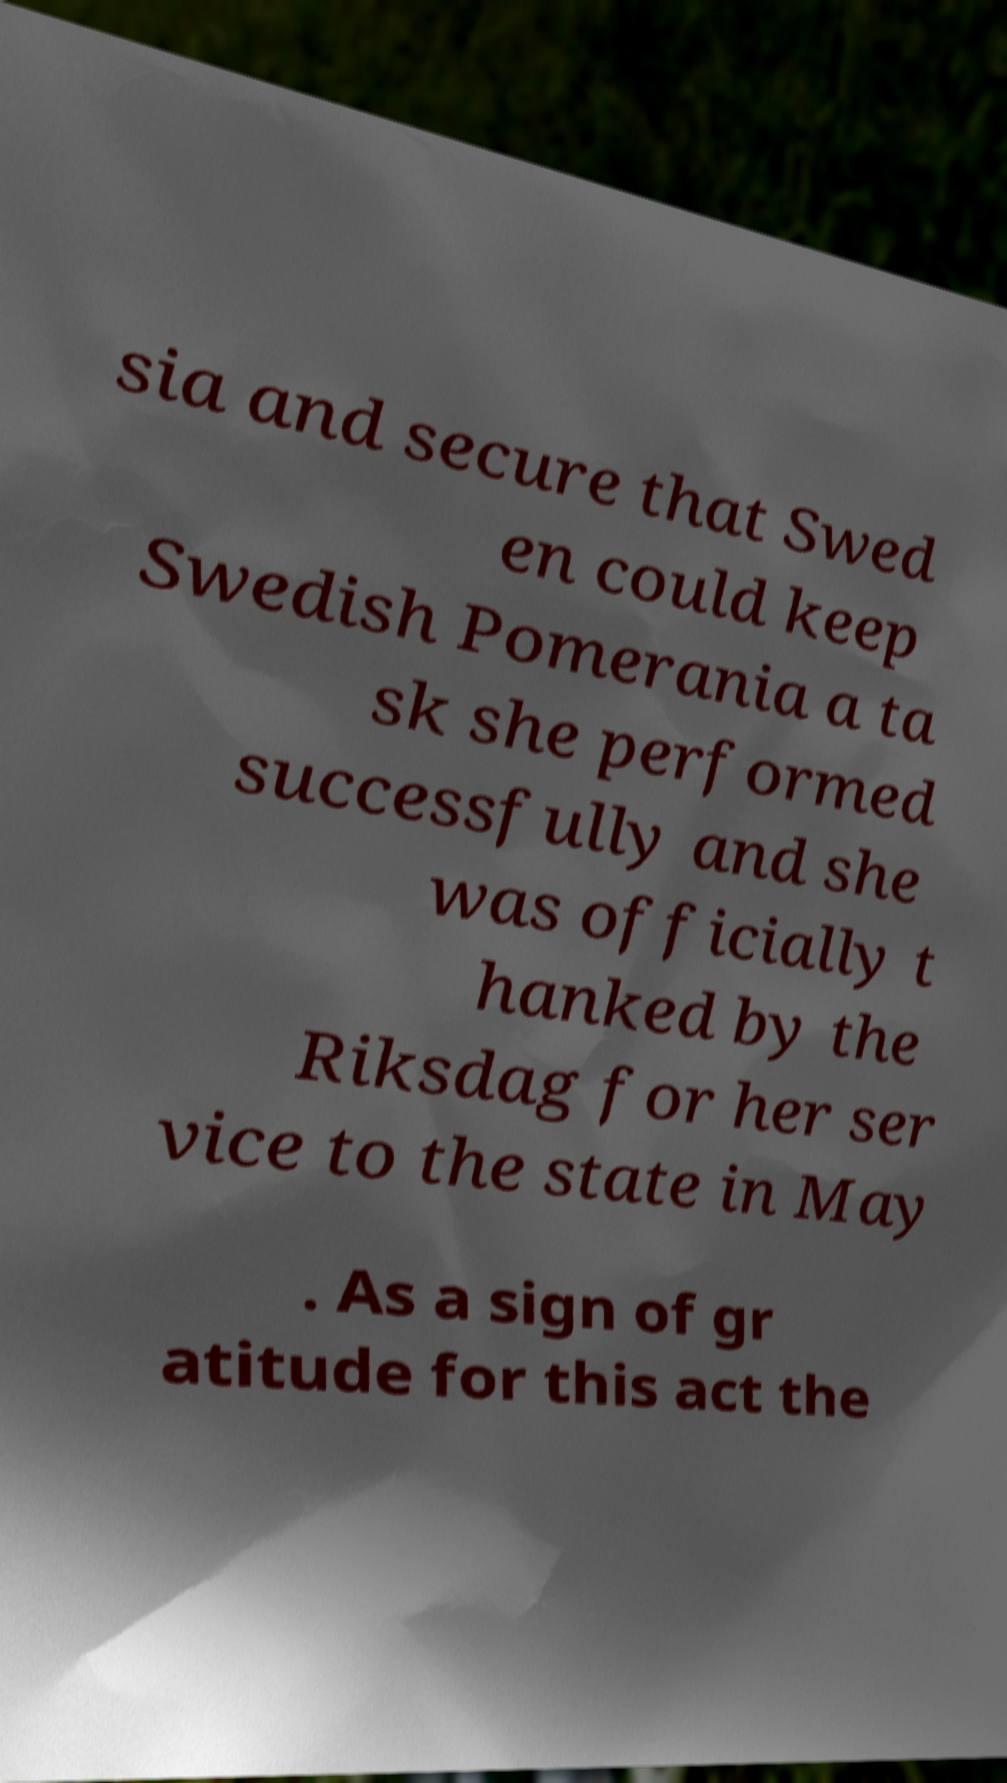What messages or text are displayed in this image? I need them in a readable, typed format. sia and secure that Swed en could keep Swedish Pomerania a ta sk she performed successfully and she was officially t hanked by the Riksdag for her ser vice to the state in May . As a sign of gr atitude for this act the 